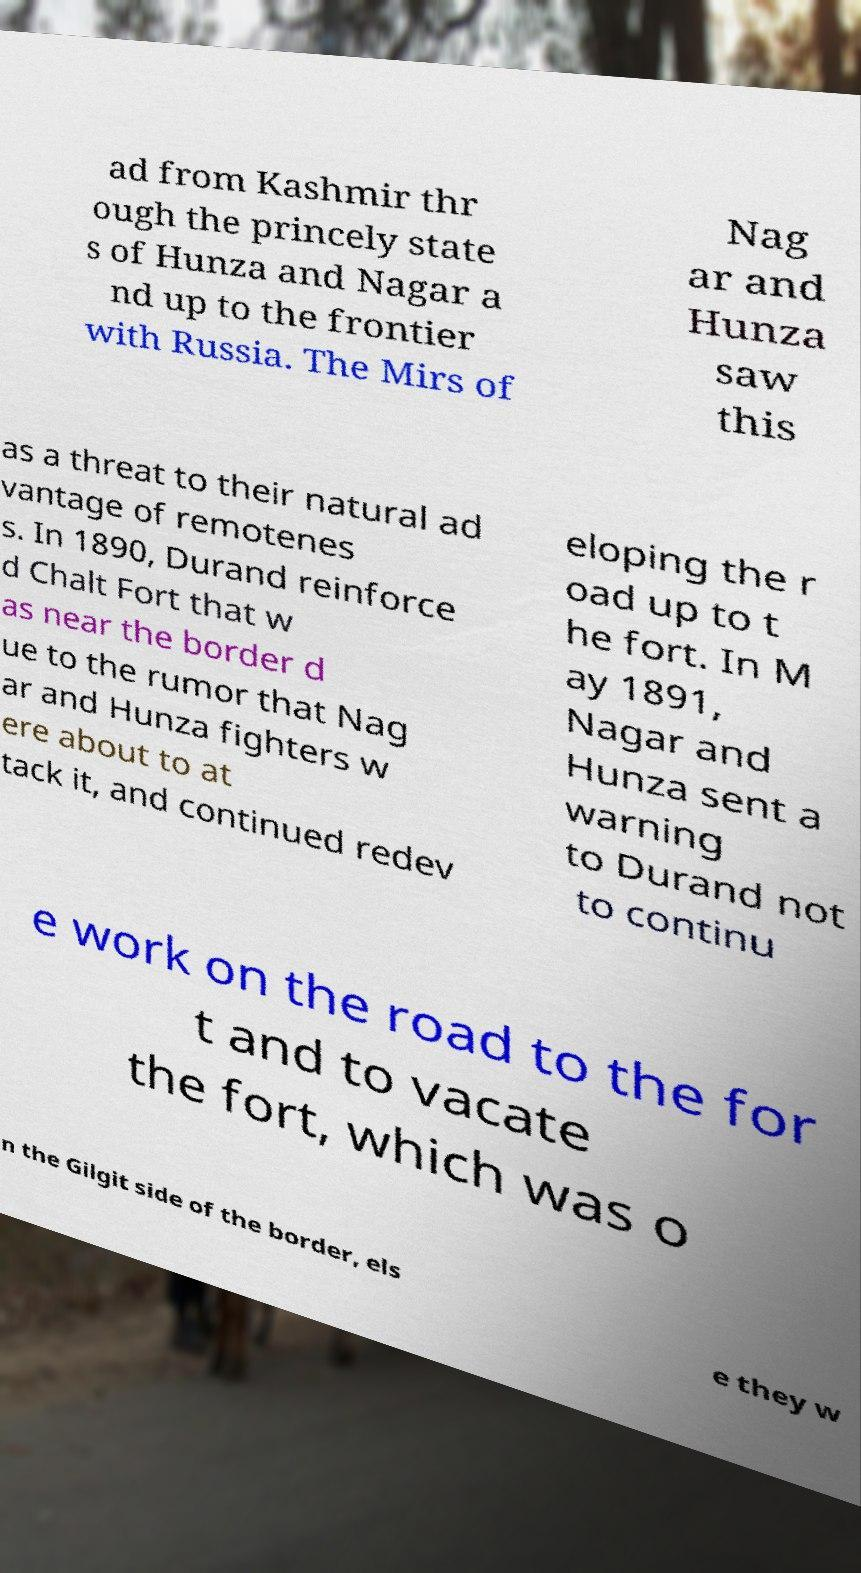Could you extract and type out the text from this image? ad from Kashmir thr ough the princely state s of Hunza and Nagar a nd up to the frontier with Russia. The Mirs of Nag ar and Hunza saw this as a threat to their natural ad vantage of remotenes s. In 1890, Durand reinforce d Chalt Fort that w as near the border d ue to the rumor that Nag ar and Hunza fighters w ere about to at tack it, and continued redev eloping the r oad up to t he fort. In M ay 1891, Nagar and Hunza sent a warning to Durand not to continu e work on the road to the for t and to vacate the fort, which was o n the Gilgit side of the border, els e they w 